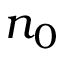Convert formula to latex. <formula><loc_0><loc_0><loc_500><loc_500>n _ { 0 }</formula> 